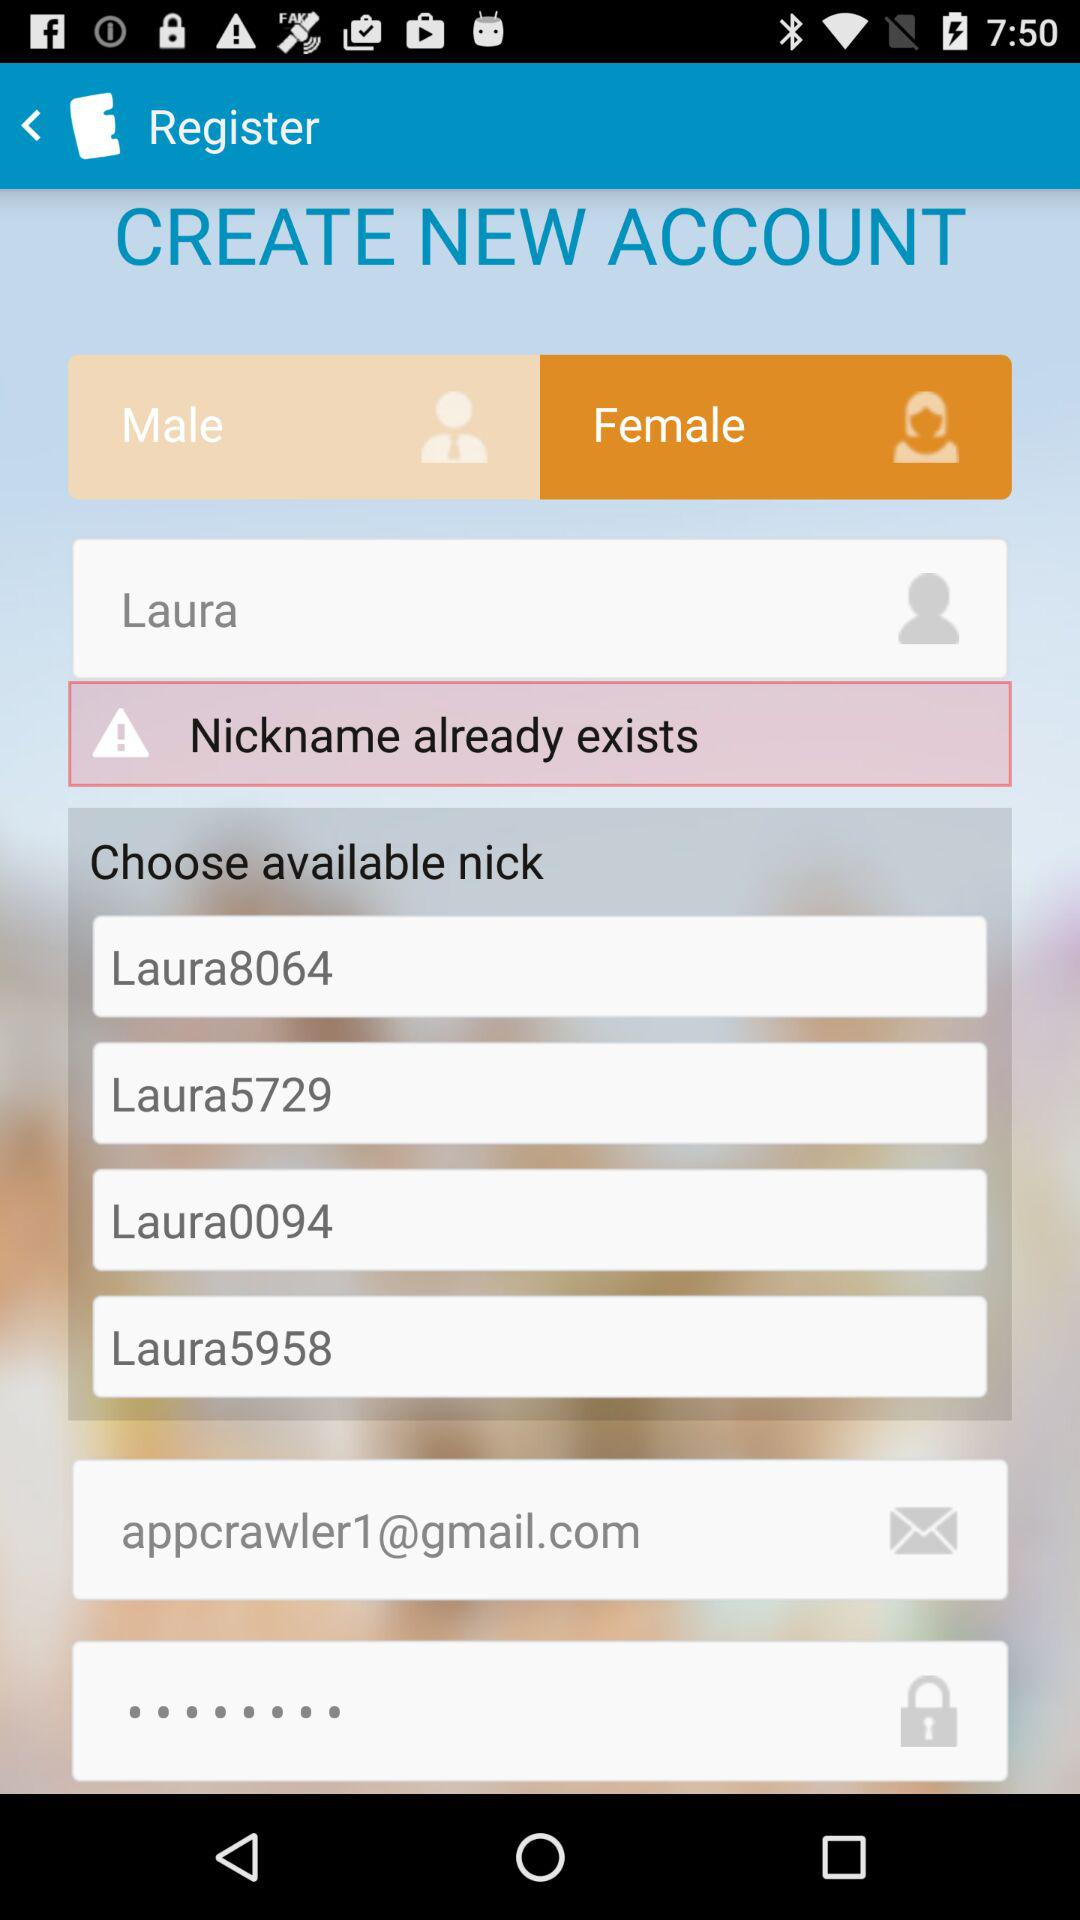What is the gender selected? The selected gender is female. 